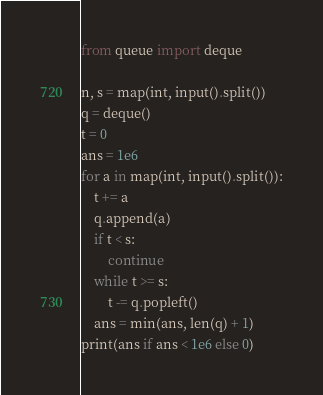Convert code to text. <code><loc_0><loc_0><loc_500><loc_500><_Python_>from queue import deque

n, s = map(int, input().split())
q = deque()
t = 0
ans = 1e6
for a in map(int, input().split()):
    t += a
    q.append(a)
    if t < s:
        continue
    while t >= s:
        t -= q.popleft()
    ans = min(ans, len(q) + 1)
print(ans if ans < 1e6 else 0)</code> 